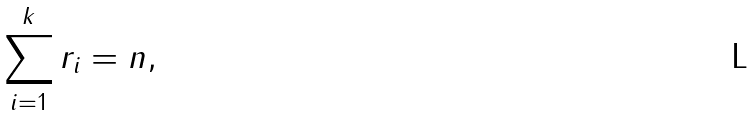Convert formula to latex. <formula><loc_0><loc_0><loc_500><loc_500>\sum _ { i = 1 } ^ { k } r _ { i } = n ,</formula> 